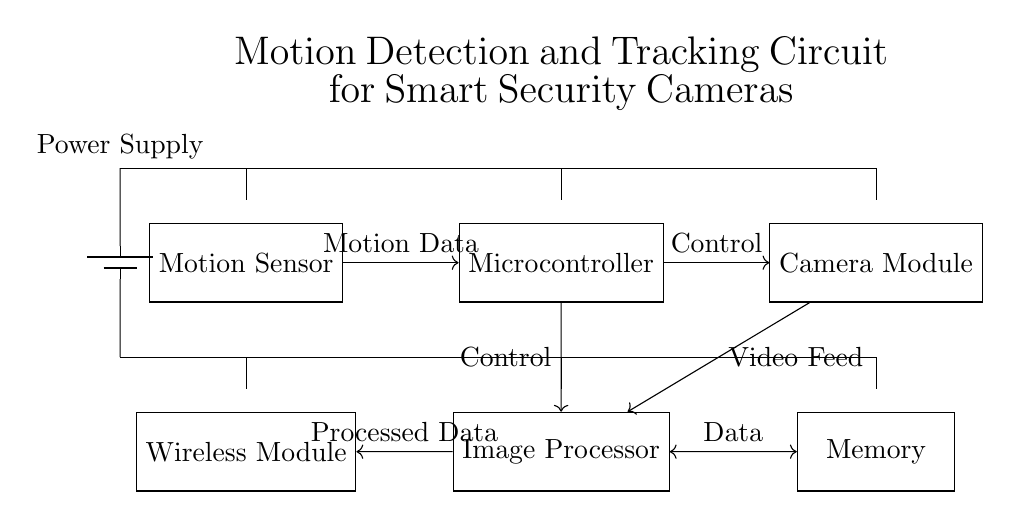What is the main function of the motion sensor? The motion sensor detects movement, sending data to the microcontroller for further processing.
Answer: Detect movement Which components are connected to the microcontroller? The microcontroller connects to the motion sensor for input, the camera module for control, and the image processor for data processing.
Answer: Motion sensor, camera module, image processor How many main modules are in the circuit? The circuit consists of five main modules: motion sensor, microcontroller, camera module, image processor, and memory.
Answer: Five What type of data does the image processor handle? The image processor handles video feeds from the camera module and coordinates data exchange with memory.
Answer: Video feeds What role does the wireless module play in this circuit? The wireless module transmits processed data wirelessly to external devices or systems for monitoring and alerting.
Answer: Transmit processed data How is power distributed to the components? Power from the battery supplies voltage to all components, indicated by connections from the power supply to each module.
Answer: From battery to all modules What type of circuit is this? This circuit is a digital circuit designed for motion detection, tracking, and security applications.
Answer: Digital circuit 